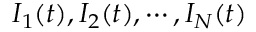<formula> <loc_0><loc_0><loc_500><loc_500>I _ { 1 } ( t ) , I _ { 2 } ( t ) , \cdots , I _ { N } ( t )</formula> 